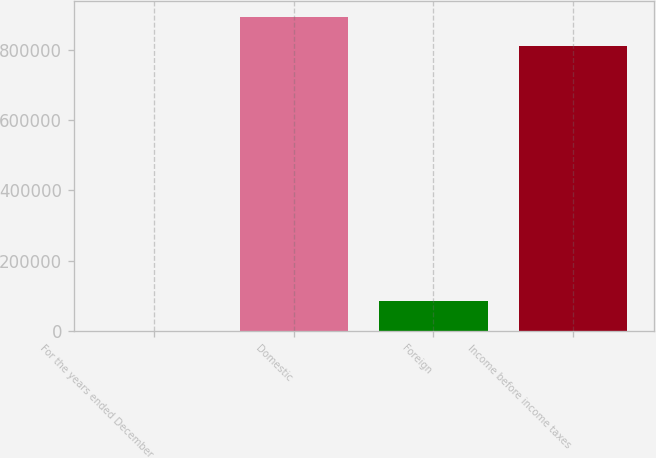Convert chart. <chart><loc_0><loc_0><loc_500><loc_500><bar_chart><fcel>For the years ended December<fcel>Domestic<fcel>Foreign<fcel>Income before income taxes<nl><fcel>2010<fcel>892564<fcel>85710.2<fcel>808864<nl></chart> 